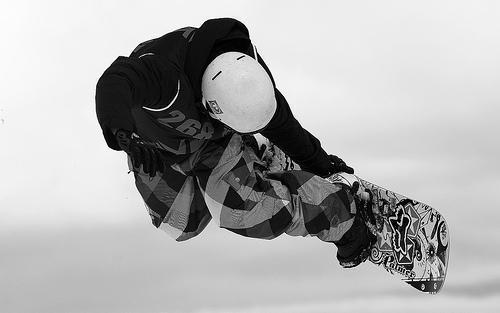How many people are in this photo?
Give a very brief answer. 1. How many helmets are there?
Give a very brief answer. 1. How many pants are there?
Give a very brief answer. 1. How many boards are there?
Give a very brief answer. 1. How many jackets are there?
Give a very brief answer. 1. 